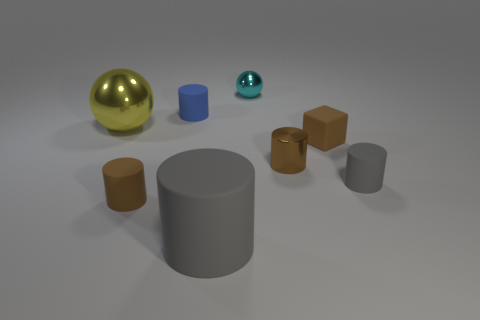Subtract 2 cylinders. How many cylinders are left? 3 Subtract all red cylinders. Subtract all blue blocks. How many cylinders are left? 5 Add 2 shiny things. How many objects exist? 10 Subtract all cubes. How many objects are left? 7 Add 6 brown matte cylinders. How many brown matte cylinders are left? 7 Add 1 tiny brown matte blocks. How many tiny brown matte blocks exist? 2 Subtract 0 red blocks. How many objects are left? 8 Subtract all brown matte cylinders. Subtract all yellow balls. How many objects are left? 6 